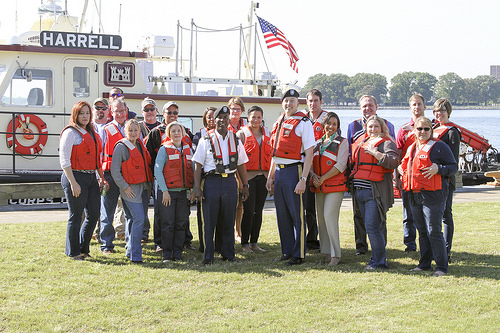<image>
Can you confirm if the lifevest is behind the girl? No. The lifevest is not behind the girl. From this viewpoint, the lifevest appears to be positioned elsewhere in the scene. 